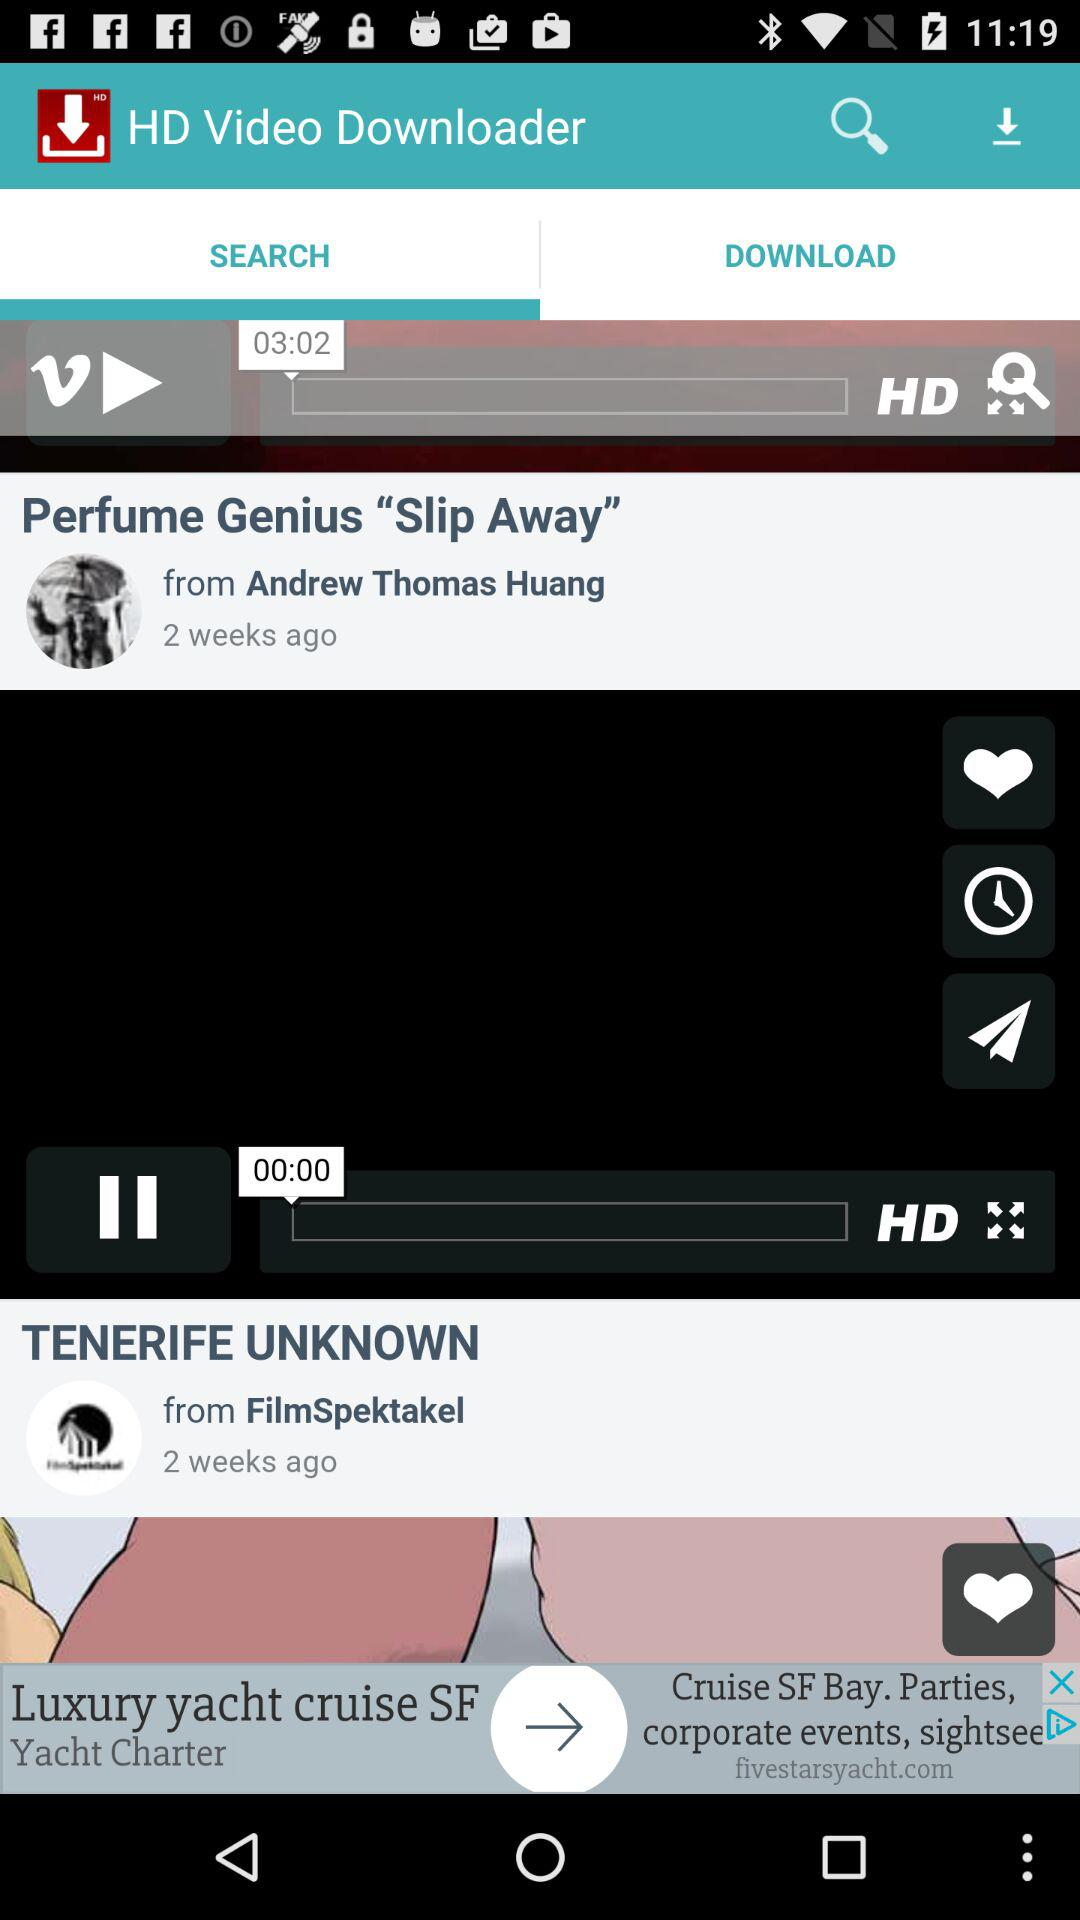What is the name of the video posted by Andrew Thomas Huang? The name of the video is "Perfume Genius Slip Away". 